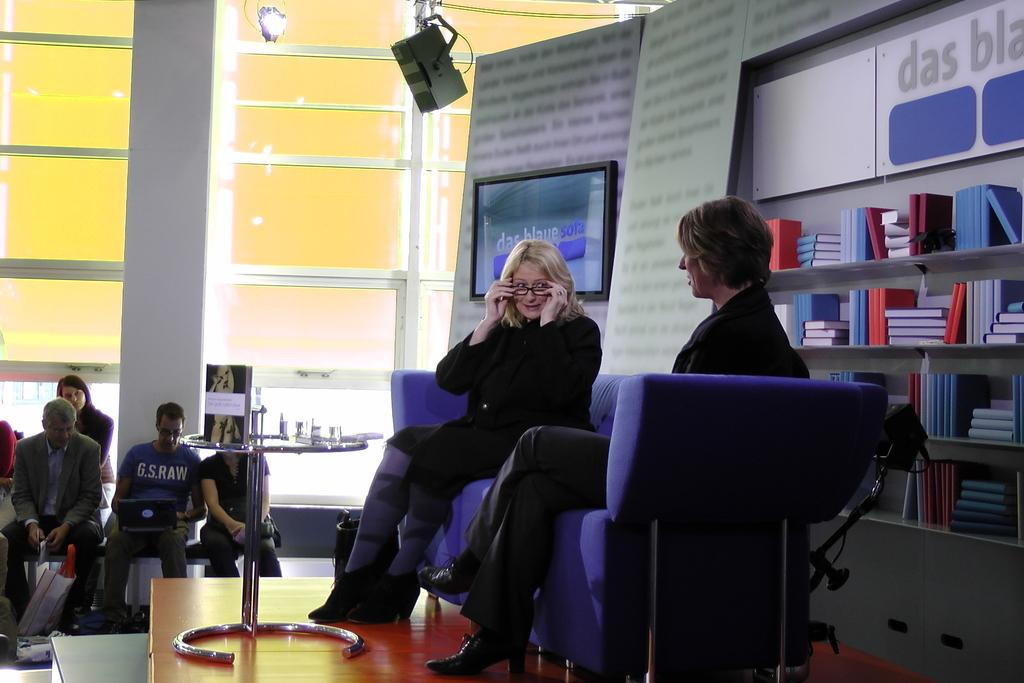How many people are in the image? There are two persons in the image. What are the two persons doing in the image? The two persons are sitting on a sofa. What can be seen in the background of the image? There is a glass window in the background of the image. What type of sound can be heard coming from the yak in the image? There is no yak present in the image, so it is not possible to determine what, if any, sound might be heard. 